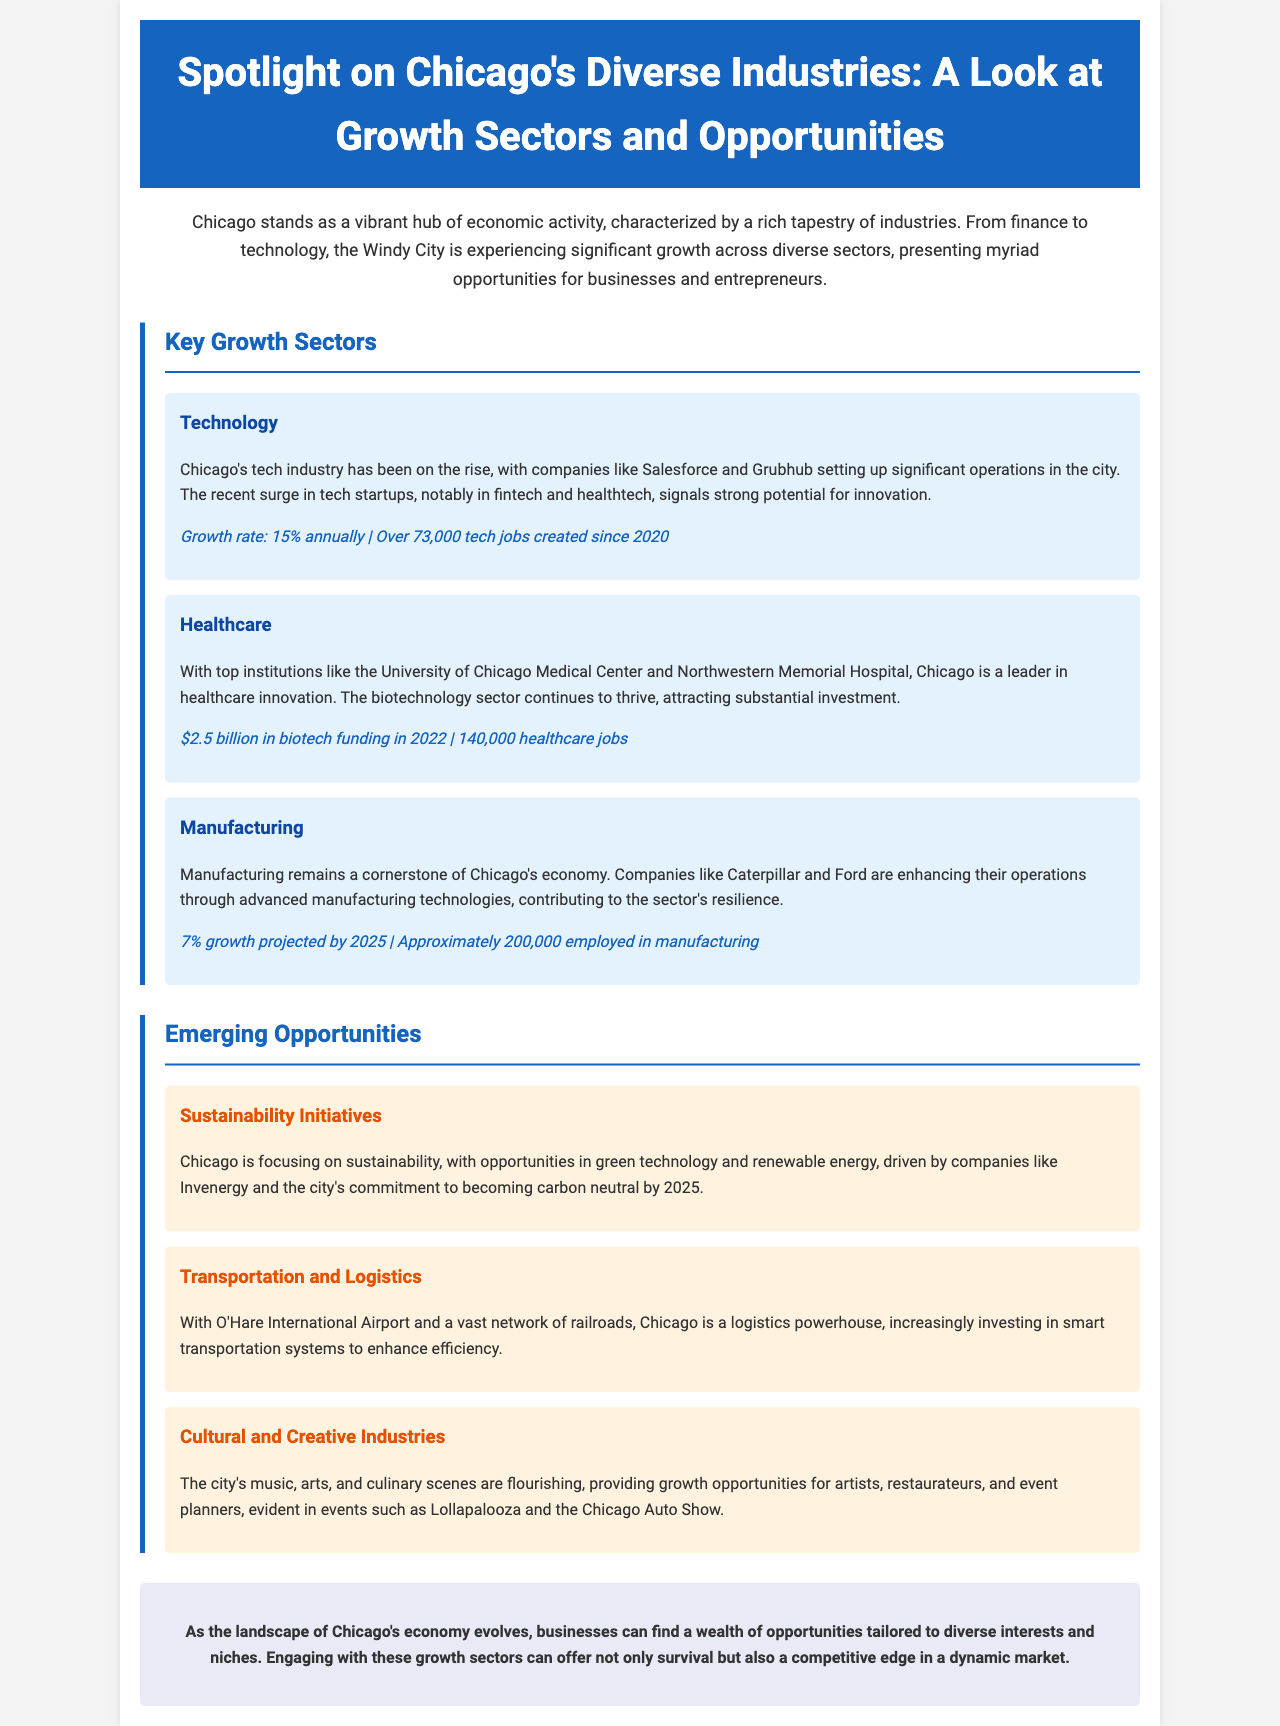What is the growth rate of the technology sector? The document states that the growth rate for the technology sector is 15% annually.
Answer: 15% How many healthcare jobs are there in Chicago? The brochure mentions that there are approximately 140,000 healthcare jobs in Chicago.
Answer: 140,000 Which two companies are highlighted in the healthcare sector? The key institutions mentioned are the University of Chicago Medical Center and Northwestern Memorial Hospital.
Answer: University of Chicago Medical Center and Northwestern Memorial Hospital What sector is projected to have a 7% growth by 2025? Manufacturing is the sector projected to grow by 7% by 2025.
Answer: Manufacturing What major initiative is Chicago focusing on? The document highlights that Chicago is focusing on sustainability initiatives.
Answer: Sustainability Initiatives What is the projected employment in manufacturing? The document states that approximately 200,000 people are employed in the manufacturing sector.
Answer: 200,000 Which city event is mentioned as part of the cultural and creative industries? Lollapalooza is mentioned as an event in the cultural and creative industries.
Answer: Lollapalooza What is the city's commitment regarding carbon neutrality? The document indicates that Chicago aims to become carbon neutral by 2025.
Answer: 2025 How much was the biotech funding in 2022? The brochure cites that there was $2.5 billion in biotech funding in 2022.
Answer: $2.5 billion 